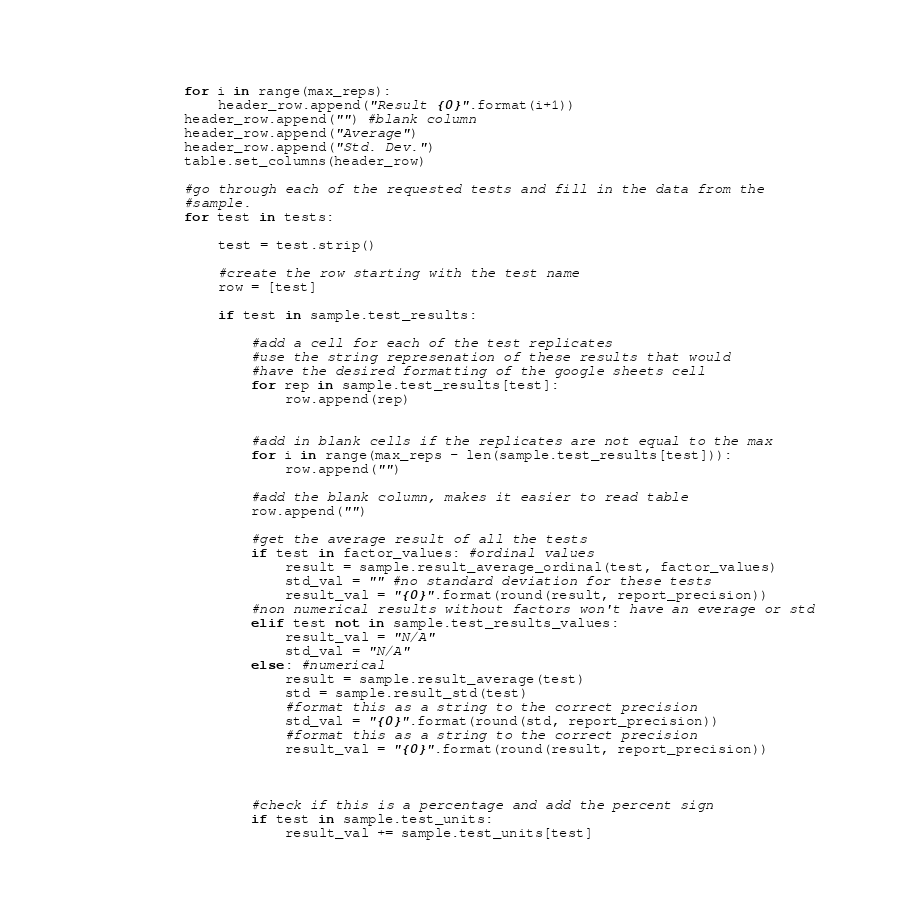<code> <loc_0><loc_0><loc_500><loc_500><_Python_>            for i in range(max_reps):
                header_row.append("Result {0}".format(i+1))
            header_row.append("") #blank column
            header_row.append("Average") 
            header_row.append("Std. Dev.") 
            table.set_columns(header_row)
  
            #go through each of the requested tests and fill in the data from the
            #sample.
            for test in tests:      
                
                test = test.strip()
                
                #create the row starting with the test name
                row = [test]
                
                if test in sample.test_results:
                    
                    #add a cell for each of the test replicates
                    #use the string represenation of these results that would
                    #have the desired formatting of the google sheets cell
                    for rep in sample.test_results[test]:
                        row.append(rep)
                        
                        
                    #add in blank cells if the replicates are not equal to the max
                    for i in range(max_reps - len(sample.test_results[test])):
                        row.append("")
                    
                    #add the blank column, makes it easier to read table
                    row.append("")
                    
                    #get the average result of all the tests
                    if test in factor_values: #ordinal values                  
                        result = sample.result_average_ordinal(test, factor_values)
                        std_val = "" #no standard deviation for these tests
                        result_val = "{0}".format(round(result, report_precision))
                    #non numerical results without factors won't have an everage or std
                    elif test not in sample.test_results_values:
                        result_val = "N/A"
                        std_val = "N/A"
                    else: #numerical
                        result = sample.result_average(test)                        
                        std = sample.result_std(test)
                        #format this as a string to the correct precision
                        std_val = "{0}".format(round(std, report_precision))
                        #format this as a string to the correct precision
                        result_val = "{0}".format(round(result, report_precision))
                    
                    
                    
                    #check if this is a percentage and add the percent sign
                    if test in sample.test_units:
                        result_val += sample.test_units[test]</code> 